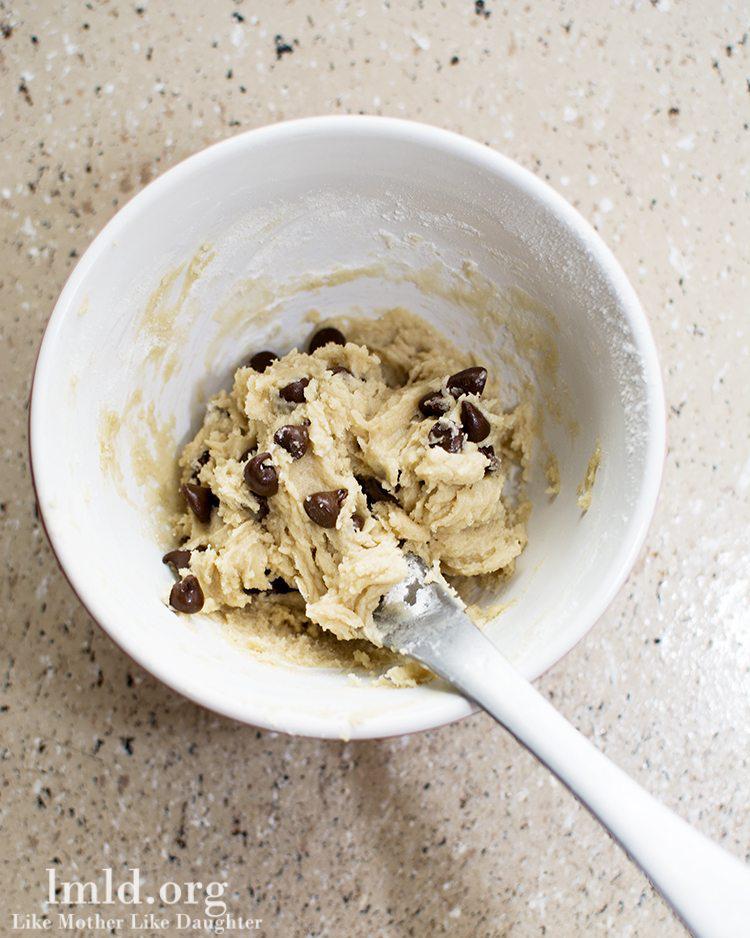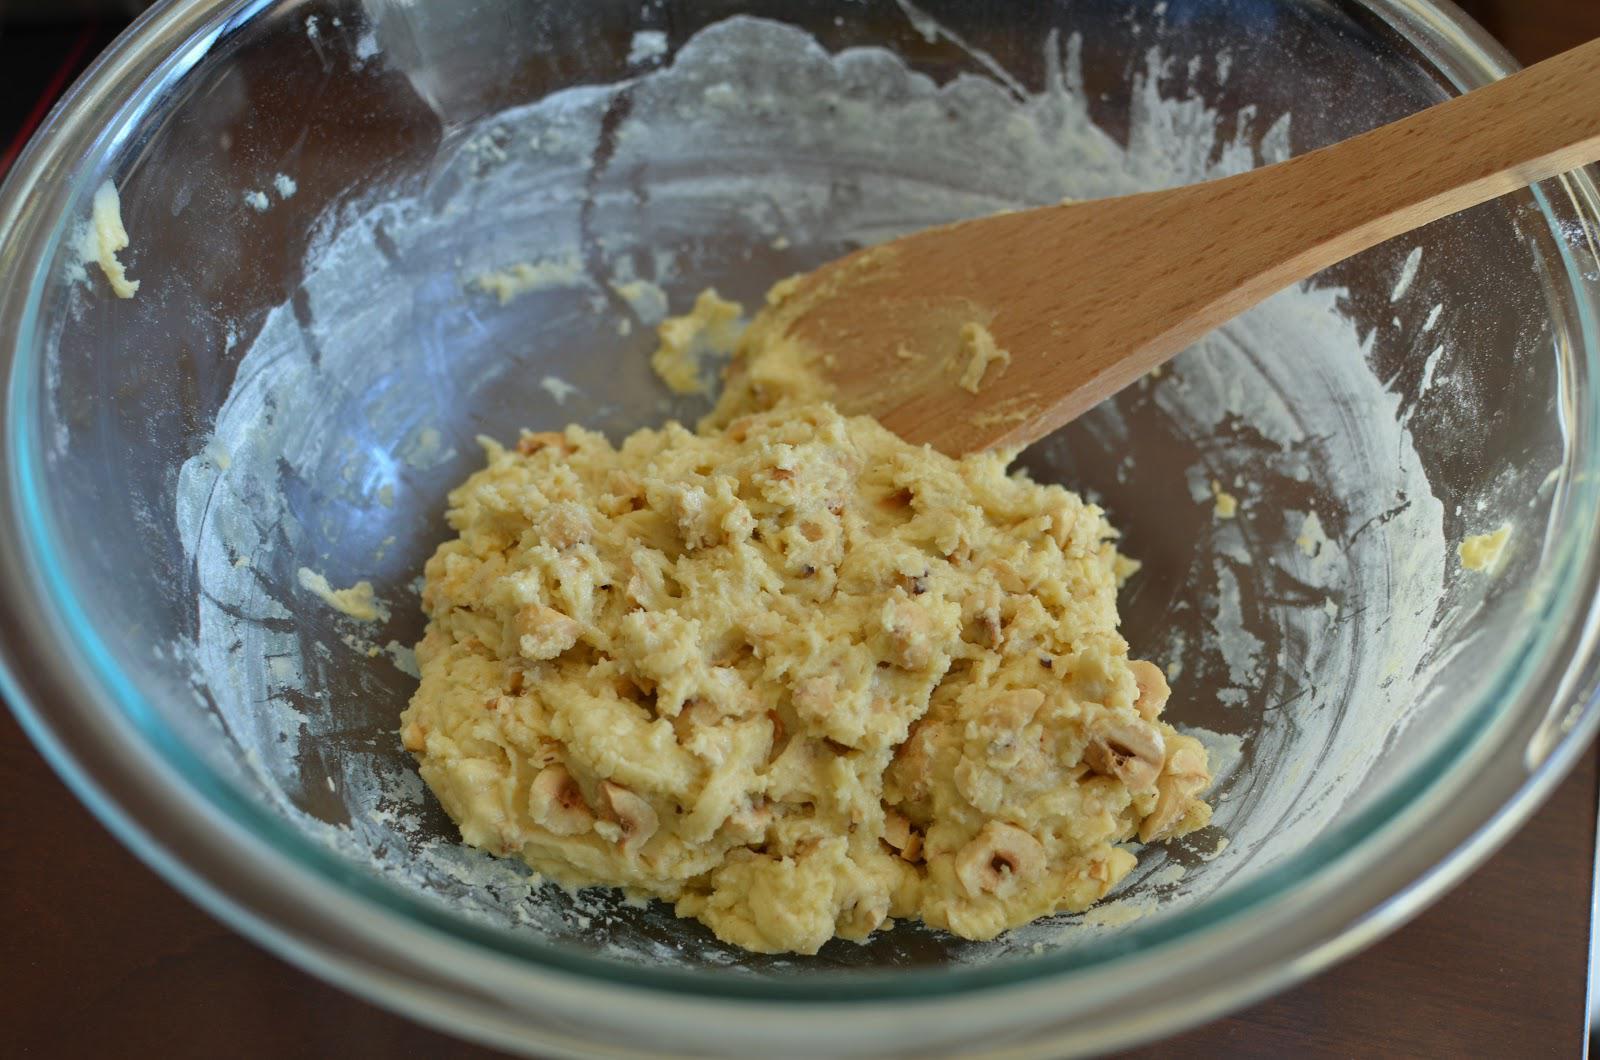The first image is the image on the left, the second image is the image on the right. Evaluate the accuracy of this statement regarding the images: "Each image features a bowl of ingredients, with a utensil in the bowl and its one handle sticking out.". Is it true? Answer yes or no. Yes. The first image is the image on the left, the second image is the image on the right. For the images displayed, is the sentence "One of the images does not contain a handheld utensil." factually correct? Answer yes or no. No. 